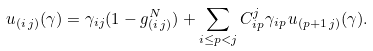Convert formula to latex. <formula><loc_0><loc_0><loc_500><loc_500>u _ { ( i \, j ) } ( \gamma ) = \gamma _ { i j } ( 1 - g _ { ( i \, j ) } ^ { N } ) + \sum _ { i \leq p < j } C ^ { j } _ { i p } \gamma _ { i p } \, u _ { ( p + 1 \, j ) } ( \gamma ) .</formula> 